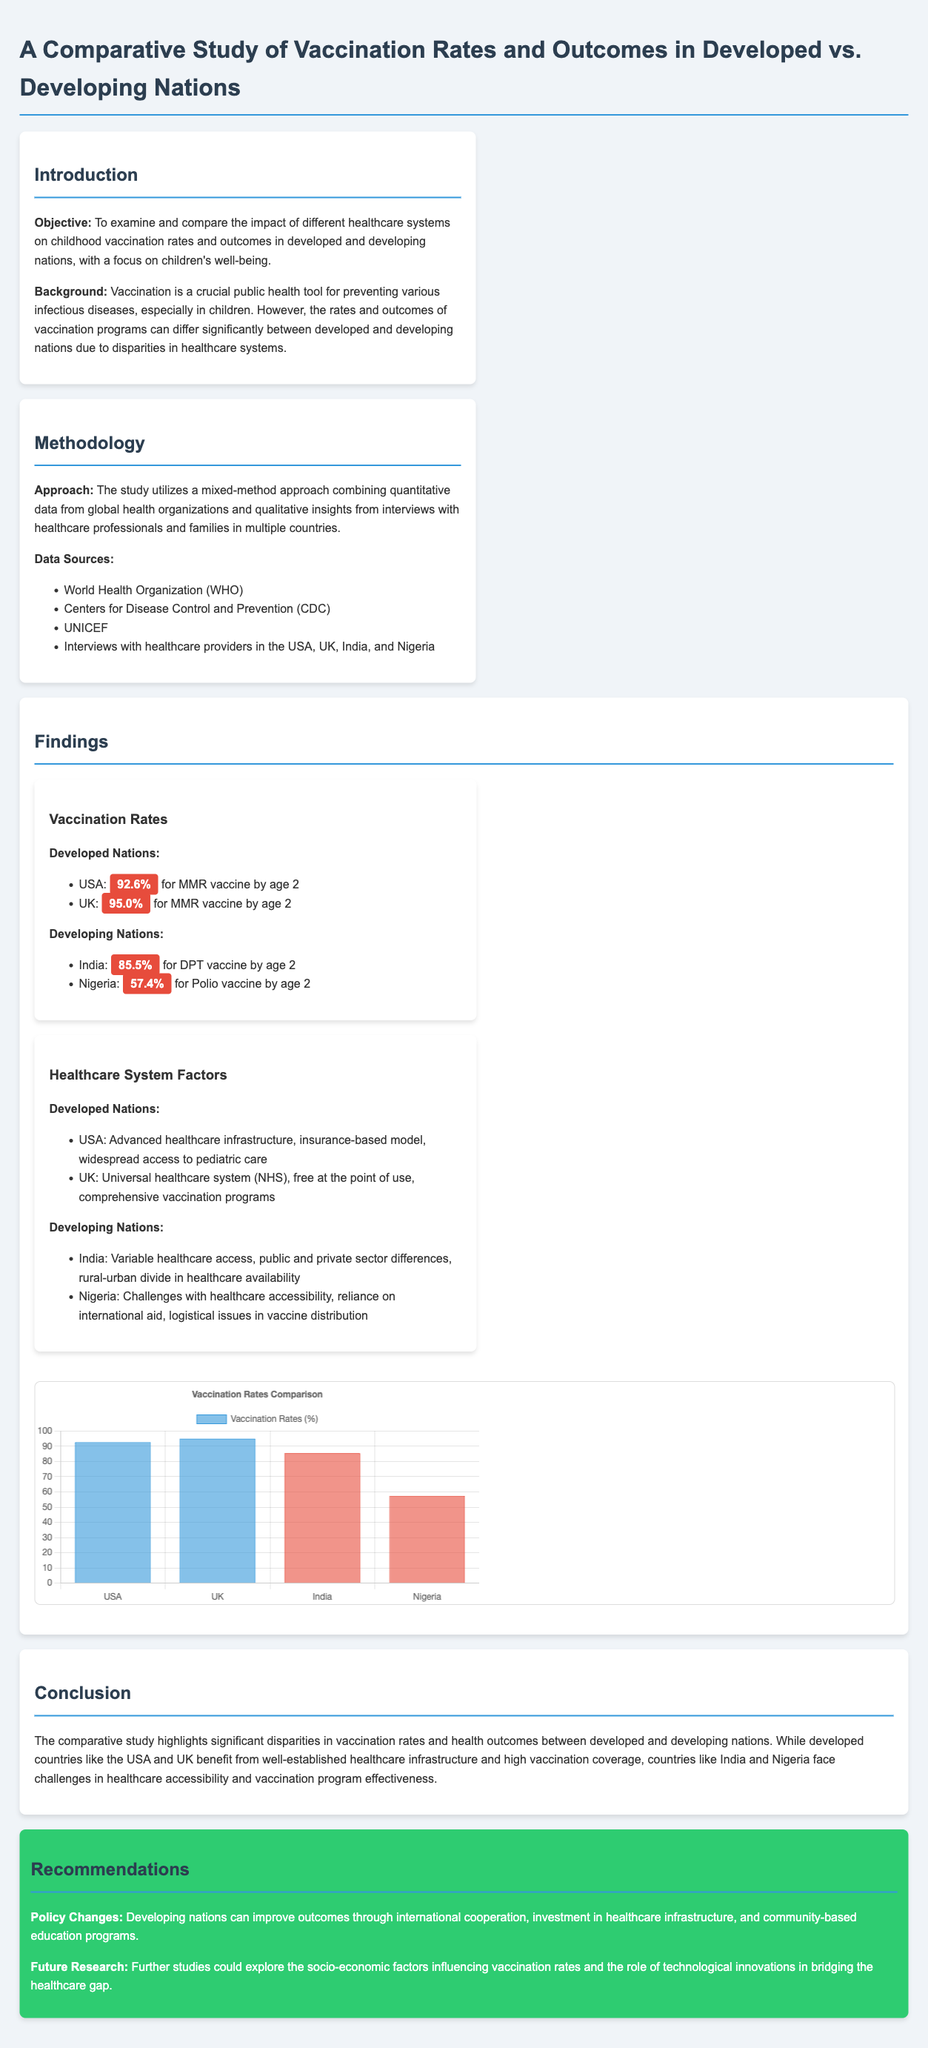What is the objective of the study? The objective is to examine and compare the impact of different healthcare systems on childhood vaccination rates and outcomes in developed and developing nations, with a focus on children's well-being.
Answer: To examine and compare the impact of different healthcare systems on childhood vaccination rates and outcomes in developed and developing nations, with a focus on children's well-being What percentage of children in the UK received the MMR vaccine by age 2? The document lists the vaccination rates for developed nations, specifically mentioning the UK.
Answer: 95.0% Which country had the lowest vaccination rate for children by age 2? The document provides vaccination rates for developing nations and indicates which is the lowest.
Answer: Nigeria What healthcare system does the UK have? The document discusses the healthcare systems of developed nations and specifies the system in the UK.
Answer: Universal healthcare system (NHS) What can developing nations do to improve vaccination outcomes? The document outlines recommendations for improving vaccination outcomes in developing nations.
Answer: International cooperation, investment in healthcare infrastructure, and community-based education programs 